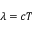<formula> <loc_0><loc_0><loc_500><loc_500>\lambda = c T</formula> 